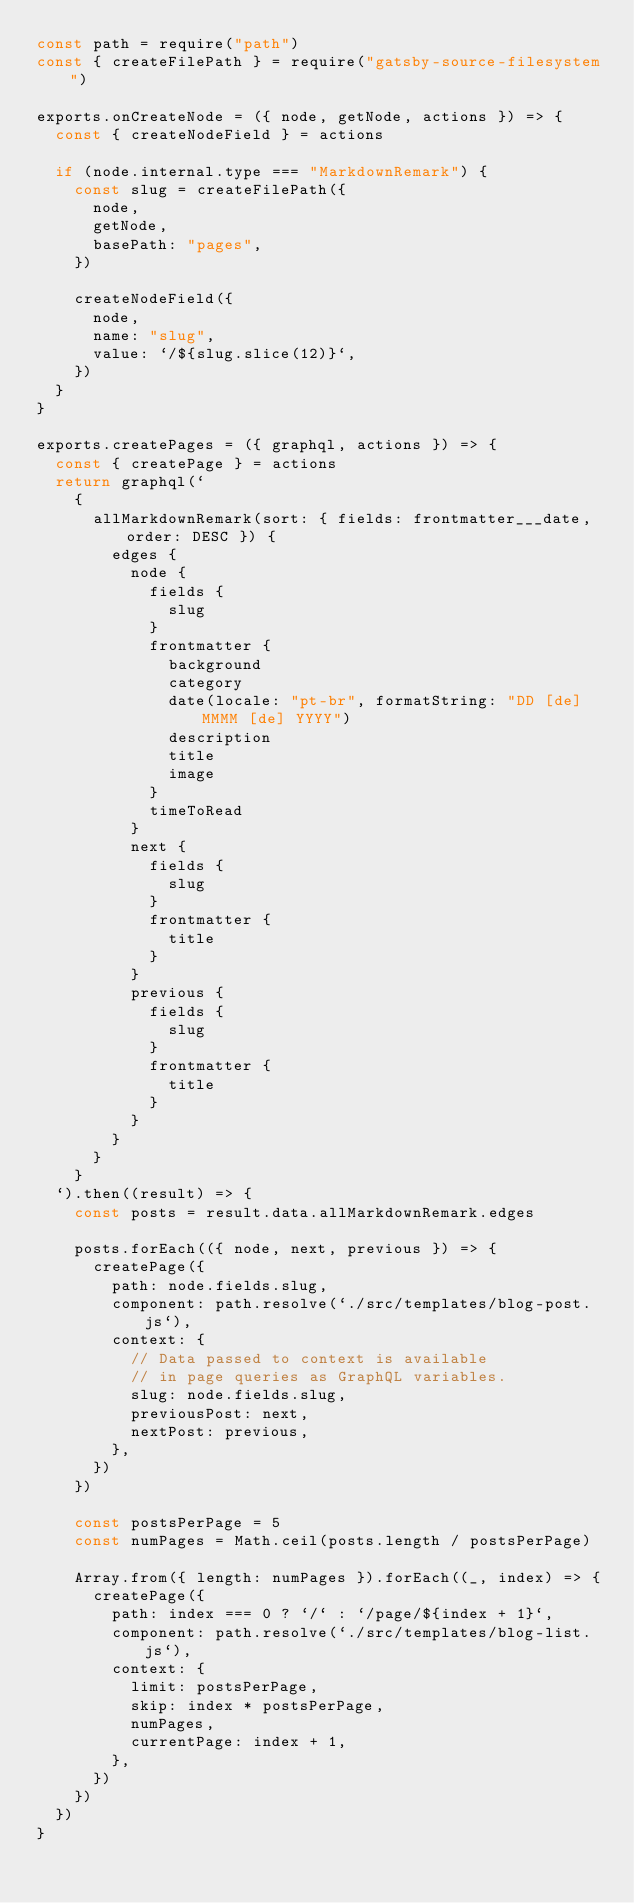<code> <loc_0><loc_0><loc_500><loc_500><_JavaScript_>const path = require("path")
const { createFilePath } = require("gatsby-source-filesystem")

exports.onCreateNode = ({ node, getNode, actions }) => {
  const { createNodeField } = actions

  if (node.internal.type === "MarkdownRemark") {
    const slug = createFilePath({
      node,
      getNode,
      basePath: "pages",
    })

    createNodeField({
      node,
      name: "slug",
      value: `/${slug.slice(12)}`,
    })
  }
}

exports.createPages = ({ graphql, actions }) => {
  const { createPage } = actions
  return graphql(`
    {
      allMarkdownRemark(sort: { fields: frontmatter___date, order: DESC }) {
        edges {
          node {
            fields {
              slug
            }
            frontmatter {
              background
              category
              date(locale: "pt-br", formatString: "DD [de] MMMM [de] YYYY")
              description
              title
              image
            }
            timeToRead
          }
          next {
            fields {
              slug
            }
            frontmatter {
              title
            }
          }
          previous {
            fields {
              slug
            }
            frontmatter {
              title
            }
          }
        }
      }
    }
  `).then((result) => {
    const posts = result.data.allMarkdownRemark.edges

    posts.forEach(({ node, next, previous }) => {
      createPage({
        path: node.fields.slug,
        component: path.resolve(`./src/templates/blog-post.js`),
        context: {
          // Data passed to context is available
          // in page queries as GraphQL variables.
          slug: node.fields.slug,
          previousPost: next,
          nextPost: previous,
        },
      })
    })

    const postsPerPage = 5
    const numPages = Math.ceil(posts.length / postsPerPage)

    Array.from({ length: numPages }).forEach((_, index) => {
      createPage({
        path: index === 0 ? `/` : `/page/${index + 1}`,
        component: path.resolve(`./src/templates/blog-list.js`),
        context: {
          limit: postsPerPage,
          skip: index * postsPerPage,
          numPages,
          currentPage: index + 1,
        },
      })
    })
  })
}
</code> 